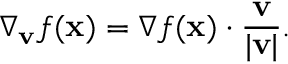Convert formula to latex. <formula><loc_0><loc_0><loc_500><loc_500>\nabla _ { v } { f } ( x ) = \nabla f ( x ) \cdot { \frac { v } { | v | } } .</formula> 